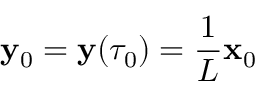Convert formula to latex. <formula><loc_0><loc_0><loc_500><loc_500>{ \mathbf y } _ { 0 } = { \mathbf y } ( \tau _ { 0 } ) = \frac { 1 } { L } { \mathbf x } _ { 0 }</formula> 